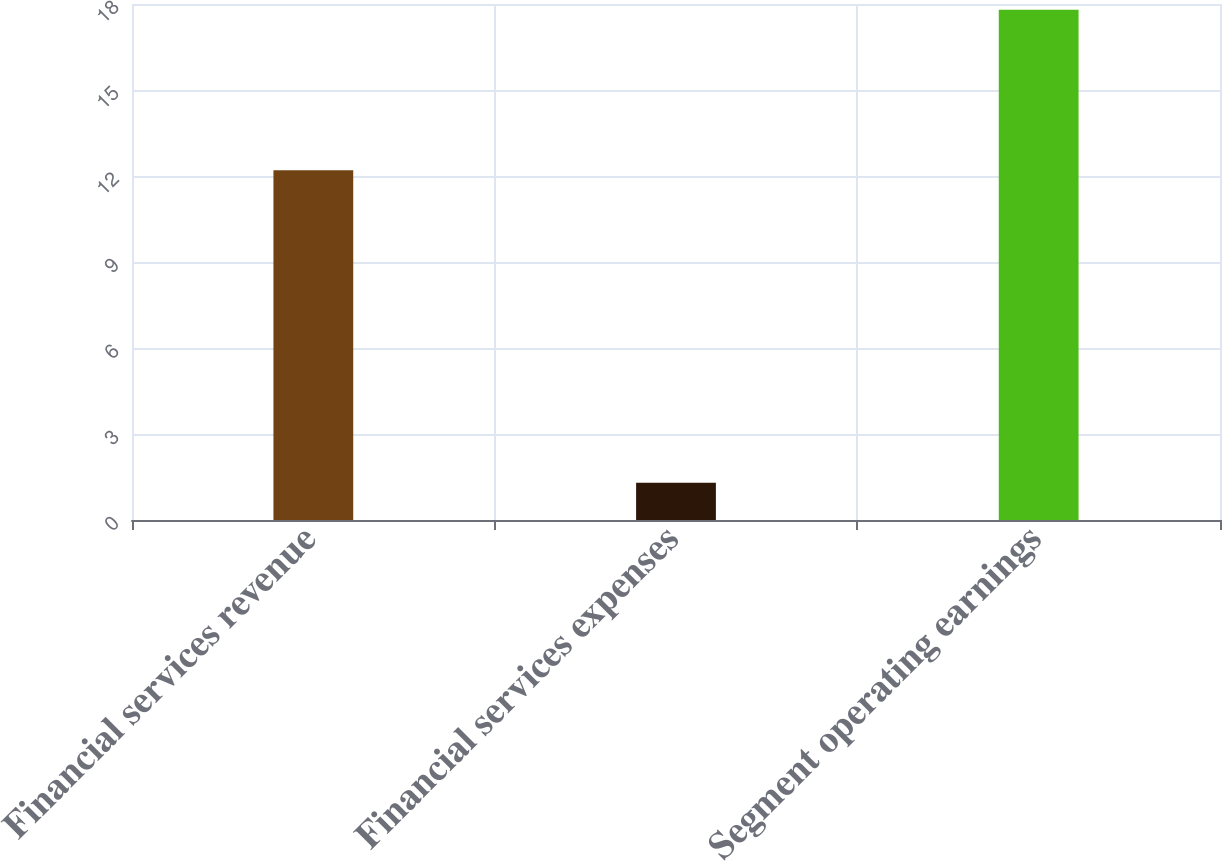Convert chart. <chart><loc_0><loc_0><loc_500><loc_500><bar_chart><fcel>Financial services revenue<fcel>Financial services expenses<fcel>Segment operating earnings<nl><fcel>12.2<fcel>1.3<fcel>17.8<nl></chart> 